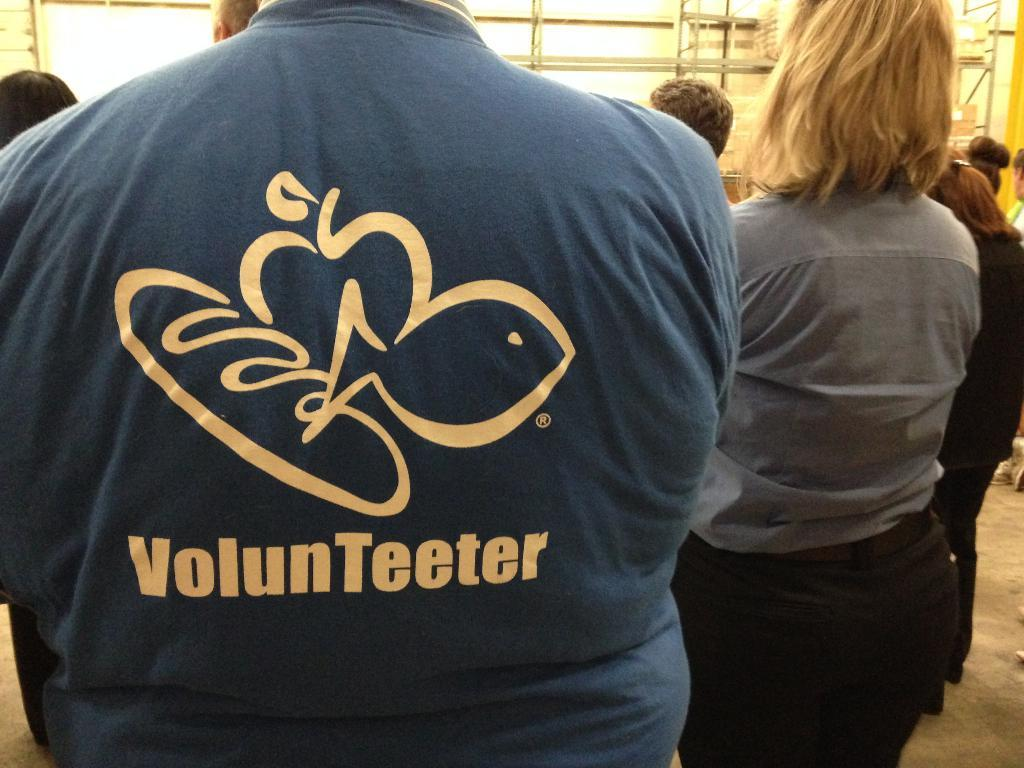<image>
Describe the image concisely. Several people standing around each other, with the person in the foreground wearing a blue shirt saying "volunteer" on it. 